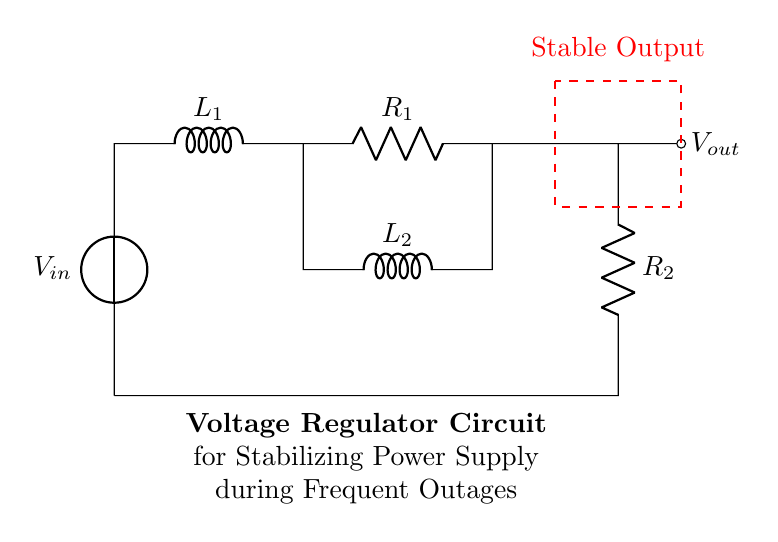What is the input voltage of the circuit? The input voltage is denoted by \( V_{in} \) in the diagram, which is represented at the leftmost side of the circuit.
Answer: \( V_{in} \) How many inductors are present in this circuit? There are two inductors labeled \( L_1 \) and \( L_2 \) in the diagram, clearly indicating that they are part of the circuit's design.
Answer: 2 What is the purpose of the resistors in this circuit? The resistors \( R_1 \) and \( R_2 \) help to limit the current and stabilize the voltage output by creating a voltage drop across them.
Answer: Stability What is the output voltage indicated in this circuit? The output voltage is represented as \( V_{out} \), shown at the right side of the circuit with an outgoing arrow, suggesting that it is the voltage supplied to a load.
Answer: \( V_{out} \) How do inductors affect the stability of the circuit? Inductors store energy in a magnetic field and resist changes in current, which helps smooth out the voltage and contributes to stabilizing the power supply during fluctuations.
Answer: Smooth voltage Is this circuit designed for AC or DC voltage? The absence of components like diodes or AC sources suggests this circuit is designed for DC voltage regulation, as indicated by the presence of the voltage source \( V_{in} \) typically associated with DC applications.
Answer: DC voltage 